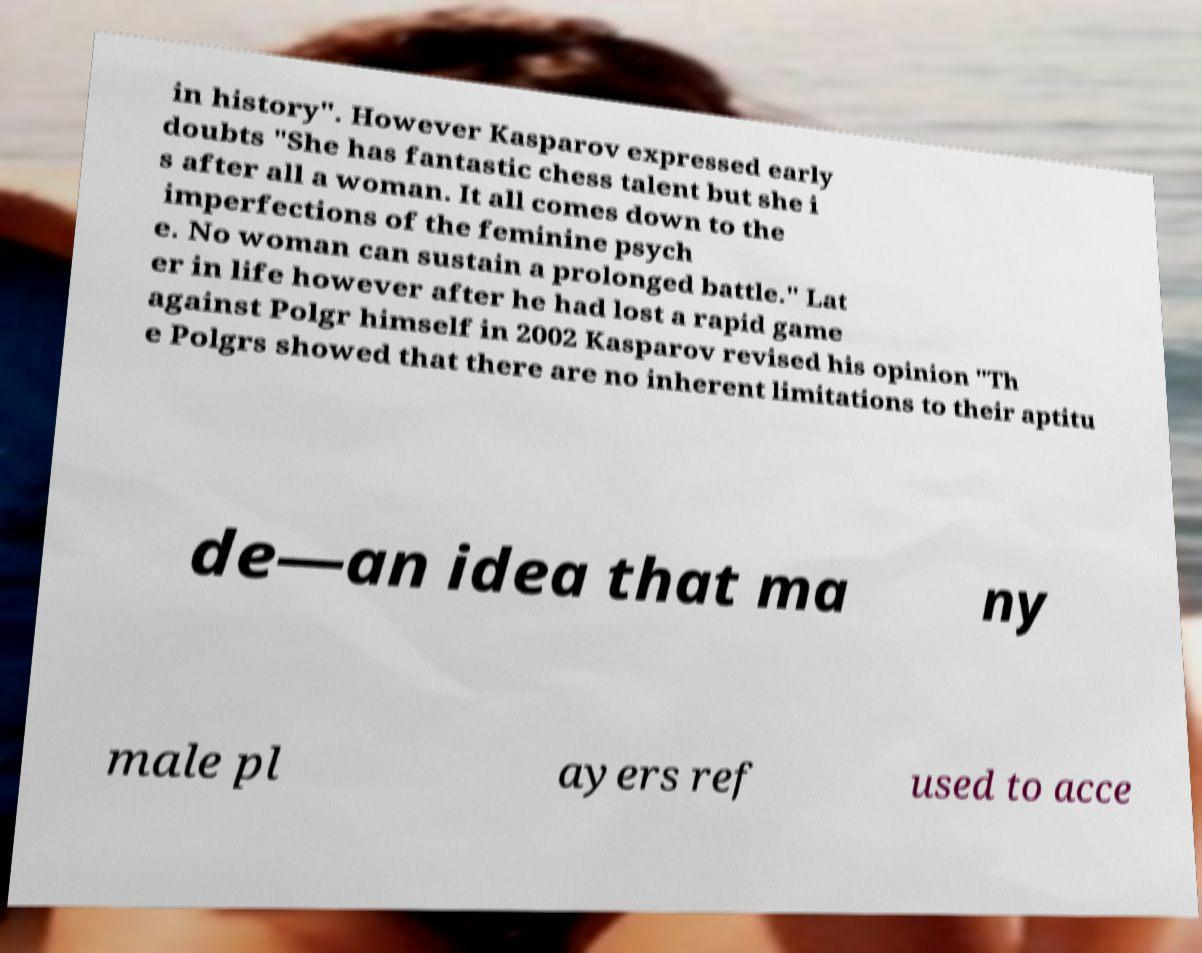Please read and relay the text visible in this image. What does it say? in history". However Kasparov expressed early doubts "She has fantastic chess talent but she i s after all a woman. It all comes down to the imperfections of the feminine psych e. No woman can sustain a prolonged battle." Lat er in life however after he had lost a rapid game against Polgr himself in 2002 Kasparov revised his opinion "Th e Polgrs showed that there are no inherent limitations to their aptitu de—an idea that ma ny male pl ayers ref used to acce 